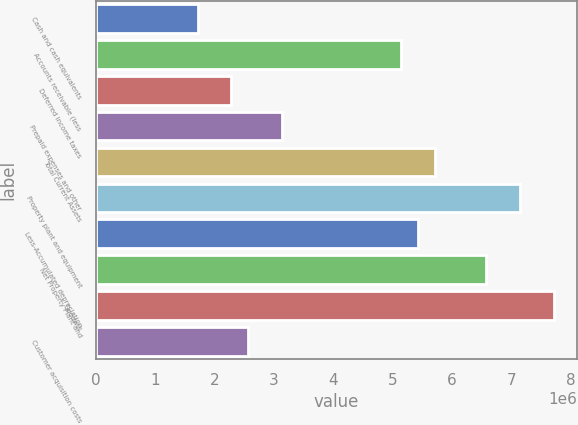Convert chart. <chart><loc_0><loc_0><loc_500><loc_500><bar_chart><fcel>Cash and cash equivalents<fcel>Accounts receivable (less<fcel>Deferred income taxes<fcel>Prepaid expenses and other<fcel>Total Current Assets<fcel>Property plant and equipment<fcel>Less-Accumulated depreciation<fcel>Net Property Plant and<fcel>Goodwill<fcel>Customer acquisition costs<nl><fcel>1.71628e+06<fcel>5.14716e+06<fcel>2.28809e+06<fcel>3.14581e+06<fcel>5.71897e+06<fcel>7.1485e+06<fcel>5.43306e+06<fcel>6.57669e+06<fcel>7.72031e+06<fcel>2.574e+06<nl></chart> 